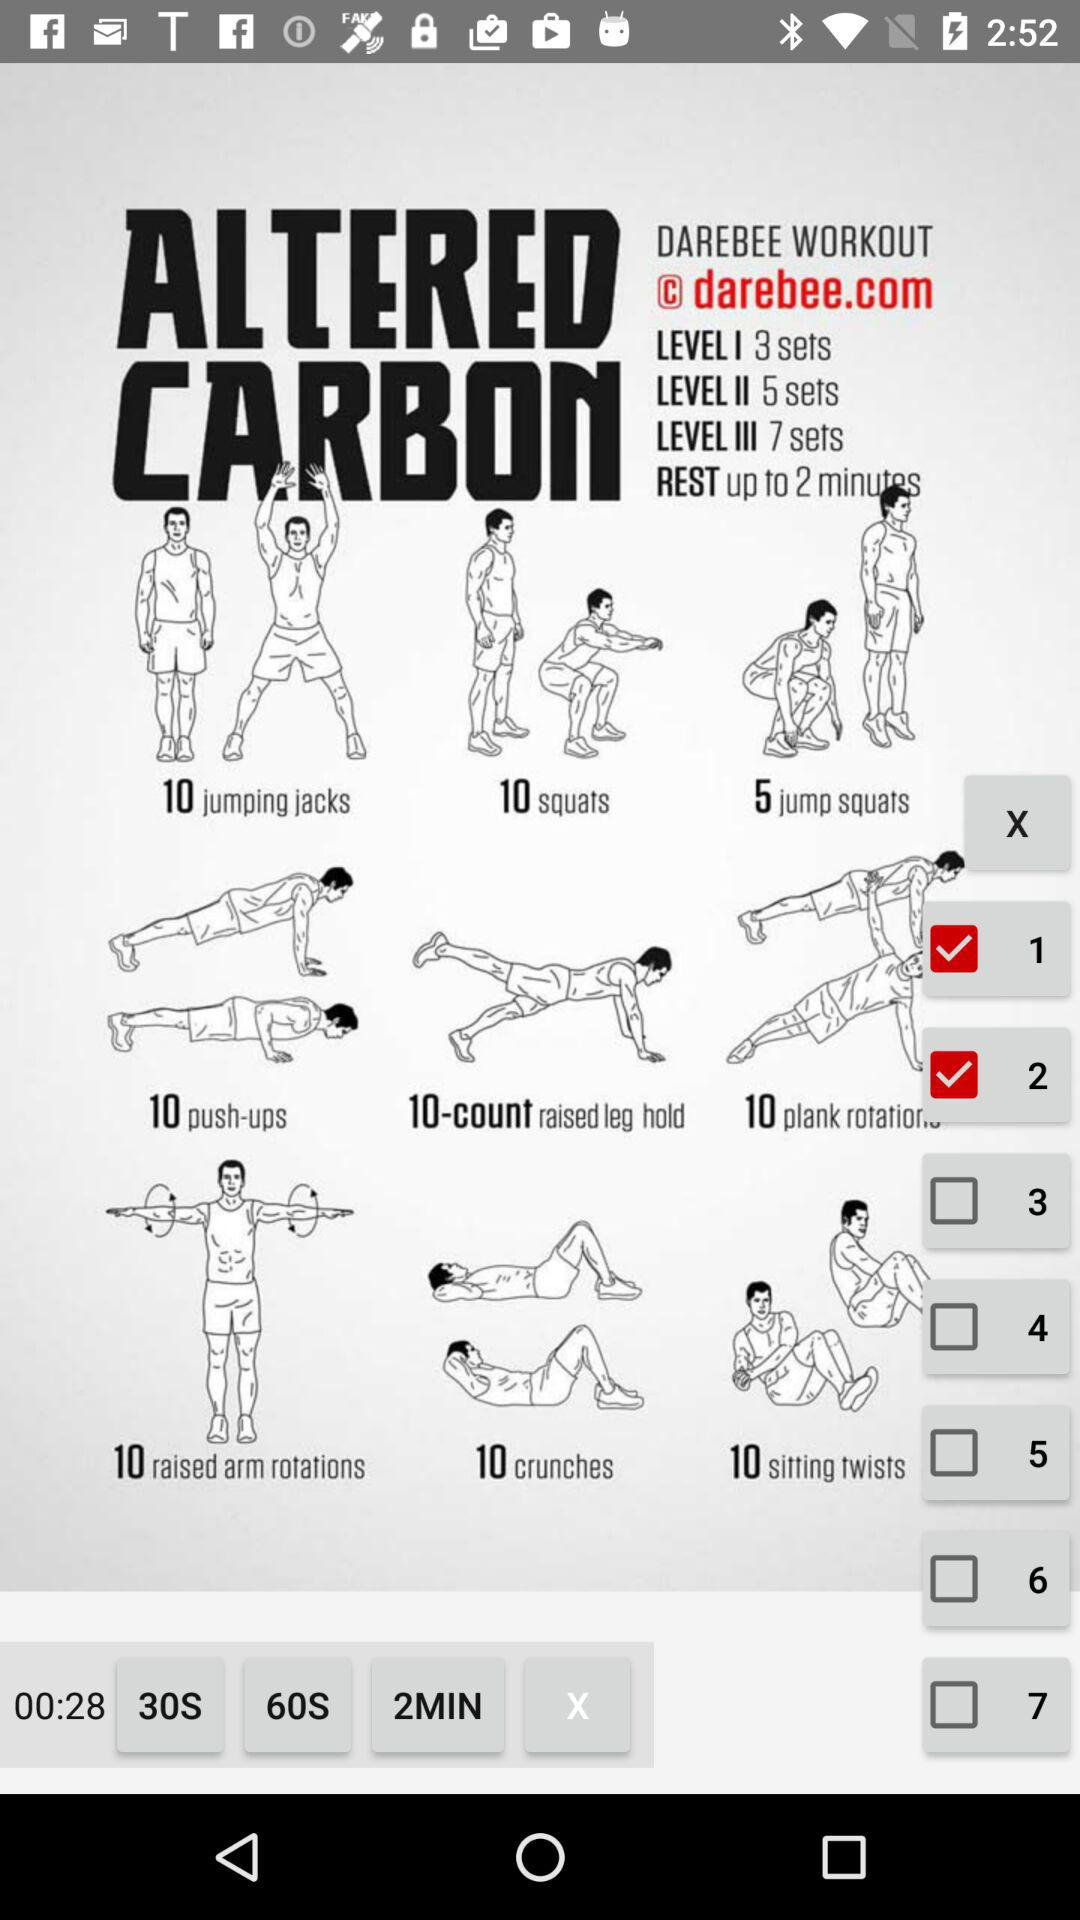Which check boxes are selected? The selected check boxes are "1" and "2". 